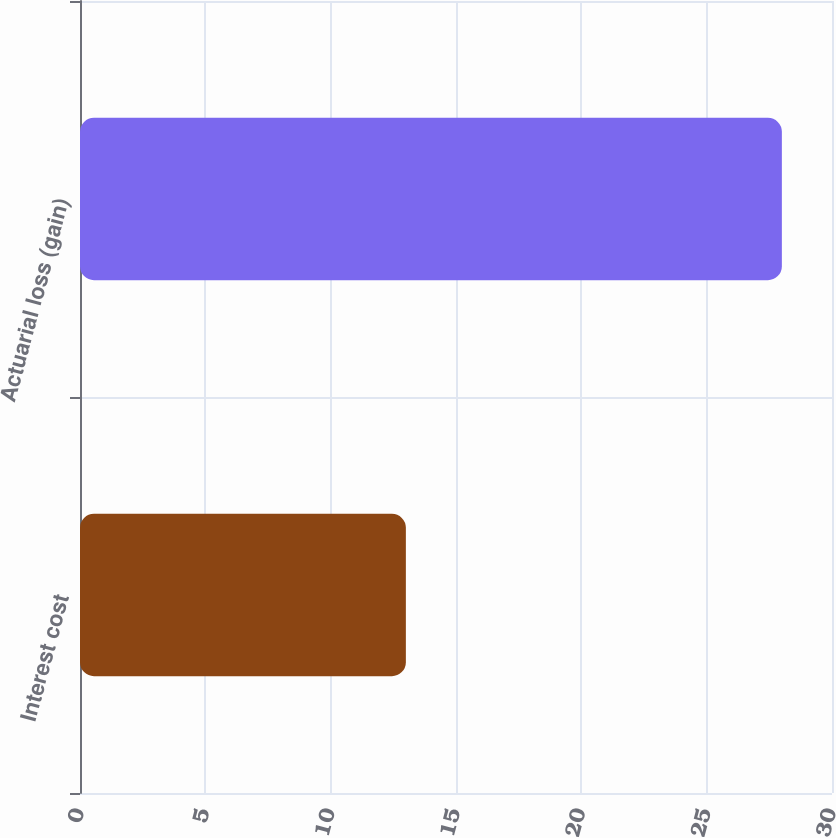Convert chart to OTSL. <chart><loc_0><loc_0><loc_500><loc_500><bar_chart><fcel>Interest cost<fcel>Actuarial loss (gain)<nl><fcel>13<fcel>28<nl></chart> 